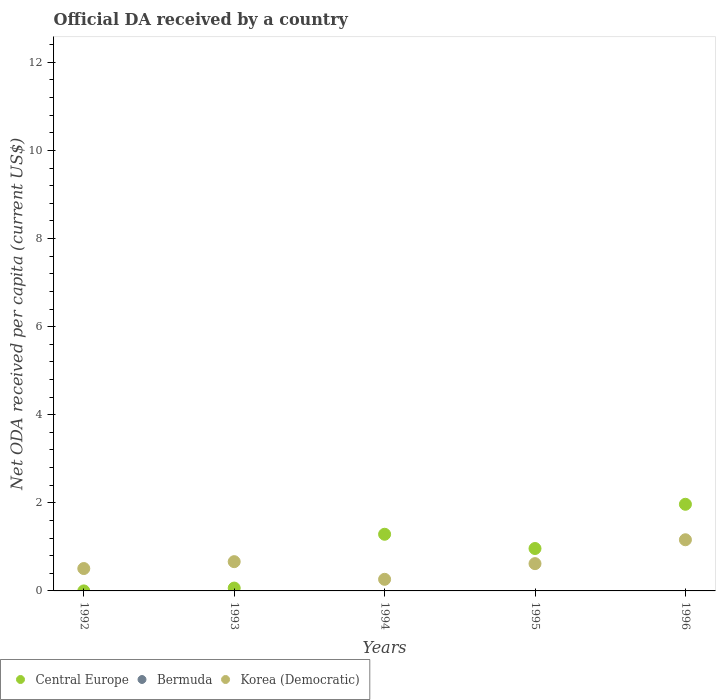Is the number of dotlines equal to the number of legend labels?
Provide a succinct answer. No. What is the ODA received in in Central Europe in 1996?
Your response must be concise. 1.97. Across all years, what is the maximum ODA received in in Central Europe?
Give a very brief answer. 1.97. In which year was the ODA received in in Korea (Democratic) maximum?
Make the answer very short. 1996. What is the total ODA received in in Korea (Democratic) in the graph?
Offer a very short reply. 3.22. What is the difference between the ODA received in in Central Europe in 1993 and that in 1994?
Give a very brief answer. -1.22. What is the difference between the ODA received in in Bermuda in 1993 and the ODA received in in Korea (Democratic) in 1992?
Your response must be concise. -0.51. What is the average ODA received in in Central Europe per year?
Offer a very short reply. 0.86. In the year 1995, what is the difference between the ODA received in in Korea (Democratic) and ODA received in in Central Europe?
Provide a succinct answer. -0.34. In how many years, is the ODA received in in Bermuda greater than 0.8 US$?
Offer a very short reply. 0. What is the ratio of the ODA received in in Central Europe in 1992 to that in 1996?
Your answer should be very brief. 4.62148913878401e-5. Is the difference between the ODA received in in Korea (Democratic) in 1992 and 1996 greater than the difference between the ODA received in in Central Europe in 1992 and 1996?
Your response must be concise. Yes. What is the difference between the highest and the second highest ODA received in in Korea (Democratic)?
Provide a short and direct response. 0.5. What is the difference between the highest and the lowest ODA received in in Korea (Democratic)?
Make the answer very short. 0.9. Is it the case that in every year, the sum of the ODA received in in Korea (Democratic) and ODA received in in Bermuda  is greater than the ODA received in in Central Europe?
Ensure brevity in your answer.  No. Does the ODA received in in Central Europe monotonically increase over the years?
Offer a terse response. No. Are the values on the major ticks of Y-axis written in scientific E-notation?
Your answer should be very brief. No. Does the graph contain any zero values?
Your response must be concise. Yes. Where does the legend appear in the graph?
Your response must be concise. Bottom left. How are the legend labels stacked?
Offer a terse response. Horizontal. What is the title of the graph?
Offer a terse response. Official DA received by a country. What is the label or title of the Y-axis?
Give a very brief answer. Net ODA received per capita (current US$). What is the Net ODA received per capita (current US$) of Central Europe in 1992?
Your answer should be very brief. 9.09044332964904e-5. What is the Net ODA received per capita (current US$) of Korea (Democratic) in 1992?
Your response must be concise. 0.51. What is the Net ODA received per capita (current US$) in Central Europe in 1993?
Make the answer very short. 0.06. What is the Net ODA received per capita (current US$) of Korea (Democratic) in 1993?
Provide a succinct answer. 0.66. What is the Net ODA received per capita (current US$) in Central Europe in 1994?
Keep it short and to the point. 1.29. What is the Net ODA received per capita (current US$) of Bermuda in 1994?
Keep it short and to the point. 0. What is the Net ODA received per capita (current US$) in Korea (Democratic) in 1994?
Your answer should be compact. 0.26. What is the Net ODA received per capita (current US$) in Central Europe in 1995?
Offer a very short reply. 0.96. What is the Net ODA received per capita (current US$) in Bermuda in 1995?
Offer a terse response. 0. What is the Net ODA received per capita (current US$) of Korea (Democratic) in 1995?
Make the answer very short. 0.62. What is the Net ODA received per capita (current US$) of Central Europe in 1996?
Give a very brief answer. 1.97. What is the Net ODA received per capita (current US$) of Bermuda in 1996?
Ensure brevity in your answer.  0. What is the Net ODA received per capita (current US$) in Korea (Democratic) in 1996?
Provide a short and direct response. 1.16. Across all years, what is the maximum Net ODA received per capita (current US$) in Central Europe?
Your answer should be compact. 1.97. Across all years, what is the maximum Net ODA received per capita (current US$) in Korea (Democratic)?
Make the answer very short. 1.16. Across all years, what is the minimum Net ODA received per capita (current US$) of Central Europe?
Your response must be concise. 9.09044332964904e-5. Across all years, what is the minimum Net ODA received per capita (current US$) of Korea (Democratic)?
Give a very brief answer. 0.26. What is the total Net ODA received per capita (current US$) of Central Europe in the graph?
Offer a terse response. 4.28. What is the total Net ODA received per capita (current US$) in Bermuda in the graph?
Ensure brevity in your answer.  0. What is the total Net ODA received per capita (current US$) of Korea (Democratic) in the graph?
Keep it short and to the point. 3.22. What is the difference between the Net ODA received per capita (current US$) in Central Europe in 1992 and that in 1993?
Provide a short and direct response. -0.06. What is the difference between the Net ODA received per capita (current US$) in Korea (Democratic) in 1992 and that in 1993?
Keep it short and to the point. -0.16. What is the difference between the Net ODA received per capita (current US$) of Central Europe in 1992 and that in 1994?
Your answer should be compact. -1.29. What is the difference between the Net ODA received per capita (current US$) of Korea (Democratic) in 1992 and that in 1994?
Ensure brevity in your answer.  0.24. What is the difference between the Net ODA received per capita (current US$) in Central Europe in 1992 and that in 1995?
Make the answer very short. -0.96. What is the difference between the Net ODA received per capita (current US$) in Korea (Democratic) in 1992 and that in 1995?
Make the answer very short. -0.11. What is the difference between the Net ODA received per capita (current US$) in Central Europe in 1992 and that in 1996?
Provide a short and direct response. -1.97. What is the difference between the Net ODA received per capita (current US$) in Korea (Democratic) in 1992 and that in 1996?
Your answer should be very brief. -0.65. What is the difference between the Net ODA received per capita (current US$) in Central Europe in 1993 and that in 1994?
Offer a very short reply. -1.22. What is the difference between the Net ODA received per capita (current US$) of Korea (Democratic) in 1993 and that in 1994?
Provide a succinct answer. 0.4. What is the difference between the Net ODA received per capita (current US$) of Central Europe in 1993 and that in 1995?
Provide a short and direct response. -0.9. What is the difference between the Net ODA received per capita (current US$) in Korea (Democratic) in 1993 and that in 1995?
Provide a succinct answer. 0.04. What is the difference between the Net ODA received per capita (current US$) in Central Europe in 1993 and that in 1996?
Ensure brevity in your answer.  -1.9. What is the difference between the Net ODA received per capita (current US$) of Korea (Democratic) in 1993 and that in 1996?
Offer a very short reply. -0.5. What is the difference between the Net ODA received per capita (current US$) of Central Europe in 1994 and that in 1995?
Offer a very short reply. 0.32. What is the difference between the Net ODA received per capita (current US$) in Korea (Democratic) in 1994 and that in 1995?
Ensure brevity in your answer.  -0.36. What is the difference between the Net ODA received per capita (current US$) in Central Europe in 1994 and that in 1996?
Your answer should be compact. -0.68. What is the difference between the Net ODA received per capita (current US$) of Korea (Democratic) in 1994 and that in 1996?
Make the answer very short. -0.9. What is the difference between the Net ODA received per capita (current US$) in Central Europe in 1995 and that in 1996?
Ensure brevity in your answer.  -1. What is the difference between the Net ODA received per capita (current US$) in Korea (Democratic) in 1995 and that in 1996?
Your answer should be compact. -0.54. What is the difference between the Net ODA received per capita (current US$) of Central Europe in 1992 and the Net ODA received per capita (current US$) of Korea (Democratic) in 1993?
Provide a short and direct response. -0.66. What is the difference between the Net ODA received per capita (current US$) in Central Europe in 1992 and the Net ODA received per capita (current US$) in Korea (Democratic) in 1994?
Offer a terse response. -0.26. What is the difference between the Net ODA received per capita (current US$) of Central Europe in 1992 and the Net ODA received per capita (current US$) of Korea (Democratic) in 1995?
Offer a very short reply. -0.62. What is the difference between the Net ODA received per capita (current US$) in Central Europe in 1992 and the Net ODA received per capita (current US$) in Korea (Democratic) in 1996?
Your answer should be very brief. -1.16. What is the difference between the Net ODA received per capita (current US$) in Central Europe in 1993 and the Net ODA received per capita (current US$) in Korea (Democratic) in 1994?
Your answer should be compact. -0.2. What is the difference between the Net ODA received per capita (current US$) in Central Europe in 1993 and the Net ODA received per capita (current US$) in Korea (Democratic) in 1995?
Your answer should be compact. -0.55. What is the difference between the Net ODA received per capita (current US$) in Central Europe in 1993 and the Net ODA received per capita (current US$) in Korea (Democratic) in 1996?
Provide a succinct answer. -1.1. What is the difference between the Net ODA received per capita (current US$) of Central Europe in 1994 and the Net ODA received per capita (current US$) of Korea (Democratic) in 1995?
Offer a very short reply. 0.67. What is the difference between the Net ODA received per capita (current US$) of Central Europe in 1994 and the Net ODA received per capita (current US$) of Korea (Democratic) in 1996?
Your answer should be compact. 0.12. What is the difference between the Net ODA received per capita (current US$) of Central Europe in 1995 and the Net ODA received per capita (current US$) of Korea (Democratic) in 1996?
Provide a succinct answer. -0.2. What is the average Net ODA received per capita (current US$) of Central Europe per year?
Your response must be concise. 0.86. What is the average Net ODA received per capita (current US$) of Korea (Democratic) per year?
Make the answer very short. 0.64. In the year 1992, what is the difference between the Net ODA received per capita (current US$) in Central Europe and Net ODA received per capita (current US$) in Korea (Democratic)?
Offer a very short reply. -0.51. In the year 1993, what is the difference between the Net ODA received per capita (current US$) of Central Europe and Net ODA received per capita (current US$) of Korea (Democratic)?
Ensure brevity in your answer.  -0.6. In the year 1994, what is the difference between the Net ODA received per capita (current US$) in Central Europe and Net ODA received per capita (current US$) in Korea (Democratic)?
Offer a terse response. 1.02. In the year 1995, what is the difference between the Net ODA received per capita (current US$) in Central Europe and Net ODA received per capita (current US$) in Korea (Democratic)?
Ensure brevity in your answer.  0.34. In the year 1996, what is the difference between the Net ODA received per capita (current US$) in Central Europe and Net ODA received per capita (current US$) in Korea (Democratic)?
Your answer should be compact. 0.81. What is the ratio of the Net ODA received per capita (current US$) of Central Europe in 1992 to that in 1993?
Give a very brief answer. 0. What is the ratio of the Net ODA received per capita (current US$) of Korea (Democratic) in 1992 to that in 1993?
Your response must be concise. 0.77. What is the ratio of the Net ODA received per capita (current US$) in Central Europe in 1992 to that in 1994?
Give a very brief answer. 0. What is the ratio of the Net ODA received per capita (current US$) of Korea (Democratic) in 1992 to that in 1994?
Your response must be concise. 1.93. What is the ratio of the Net ODA received per capita (current US$) of Korea (Democratic) in 1992 to that in 1995?
Give a very brief answer. 0.82. What is the ratio of the Net ODA received per capita (current US$) of Korea (Democratic) in 1992 to that in 1996?
Offer a terse response. 0.44. What is the ratio of the Net ODA received per capita (current US$) in Central Europe in 1993 to that in 1994?
Provide a short and direct response. 0.05. What is the ratio of the Net ODA received per capita (current US$) of Korea (Democratic) in 1993 to that in 1994?
Keep it short and to the point. 2.52. What is the ratio of the Net ODA received per capita (current US$) of Central Europe in 1993 to that in 1995?
Your answer should be very brief. 0.07. What is the ratio of the Net ODA received per capita (current US$) in Korea (Democratic) in 1993 to that in 1995?
Your answer should be very brief. 1.07. What is the ratio of the Net ODA received per capita (current US$) of Central Europe in 1993 to that in 1996?
Your answer should be very brief. 0.03. What is the ratio of the Net ODA received per capita (current US$) in Korea (Democratic) in 1993 to that in 1996?
Ensure brevity in your answer.  0.57. What is the ratio of the Net ODA received per capita (current US$) in Central Europe in 1994 to that in 1995?
Keep it short and to the point. 1.34. What is the ratio of the Net ODA received per capita (current US$) in Korea (Democratic) in 1994 to that in 1995?
Offer a very short reply. 0.43. What is the ratio of the Net ODA received per capita (current US$) of Central Europe in 1994 to that in 1996?
Make the answer very short. 0.65. What is the ratio of the Net ODA received per capita (current US$) of Korea (Democratic) in 1994 to that in 1996?
Provide a succinct answer. 0.23. What is the ratio of the Net ODA received per capita (current US$) in Central Europe in 1995 to that in 1996?
Keep it short and to the point. 0.49. What is the ratio of the Net ODA received per capita (current US$) in Korea (Democratic) in 1995 to that in 1996?
Offer a very short reply. 0.53. What is the difference between the highest and the second highest Net ODA received per capita (current US$) in Central Europe?
Offer a terse response. 0.68. What is the difference between the highest and the second highest Net ODA received per capita (current US$) of Korea (Democratic)?
Give a very brief answer. 0.5. What is the difference between the highest and the lowest Net ODA received per capita (current US$) of Central Europe?
Offer a terse response. 1.97. What is the difference between the highest and the lowest Net ODA received per capita (current US$) of Korea (Democratic)?
Keep it short and to the point. 0.9. 